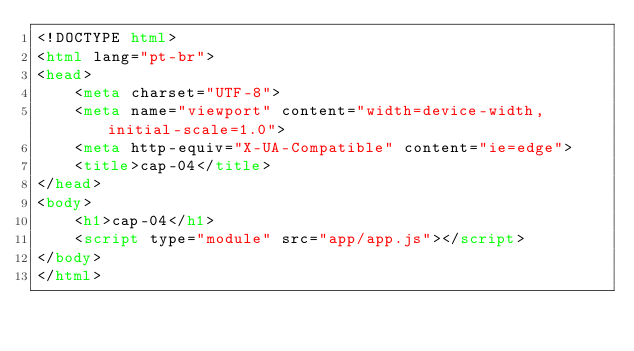Convert code to text. <code><loc_0><loc_0><loc_500><loc_500><_HTML_><!DOCTYPE html>
<html lang="pt-br">
<head>
    <meta charset="UTF-8">
    <meta name="viewport" content="width=device-width, initial-scale=1.0">
    <meta http-equiv="X-UA-Compatible" content="ie=edge">
    <title>cap-04</title>
</head>
<body>
    <h1>cap-04</h1>
    <script type="module" src="app/app.js"></script>
</body>
</html></code> 